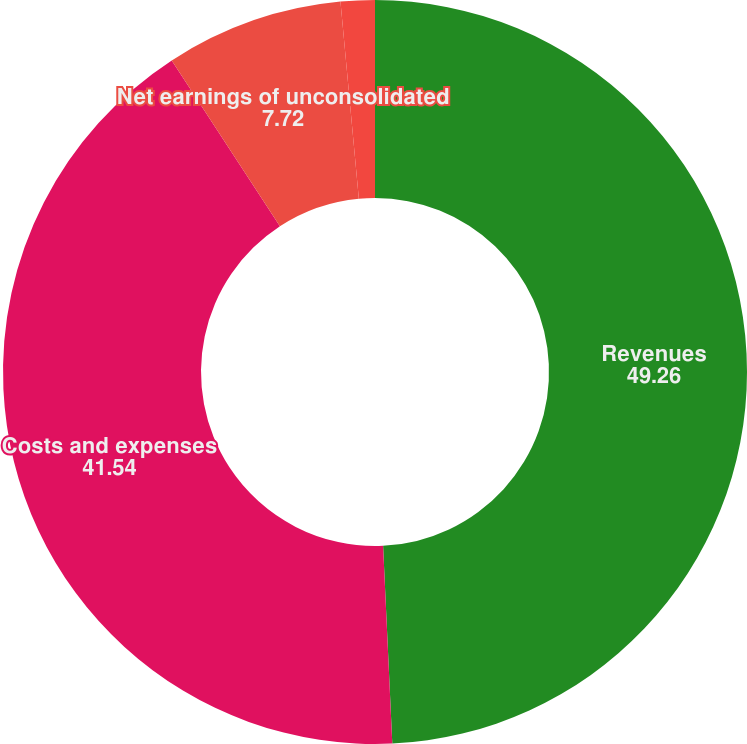Convert chart to OTSL. <chart><loc_0><loc_0><loc_500><loc_500><pie_chart><fcel>Revenues<fcel>Costs and expenses<fcel>Net earnings of unconsolidated<fcel>Company share of net earnings<nl><fcel>49.26%<fcel>41.54%<fcel>7.72%<fcel>1.48%<nl></chart> 